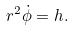Convert formula to latex. <formula><loc_0><loc_0><loc_500><loc_500>r ^ { 2 } \dot { \phi } = h .</formula> 